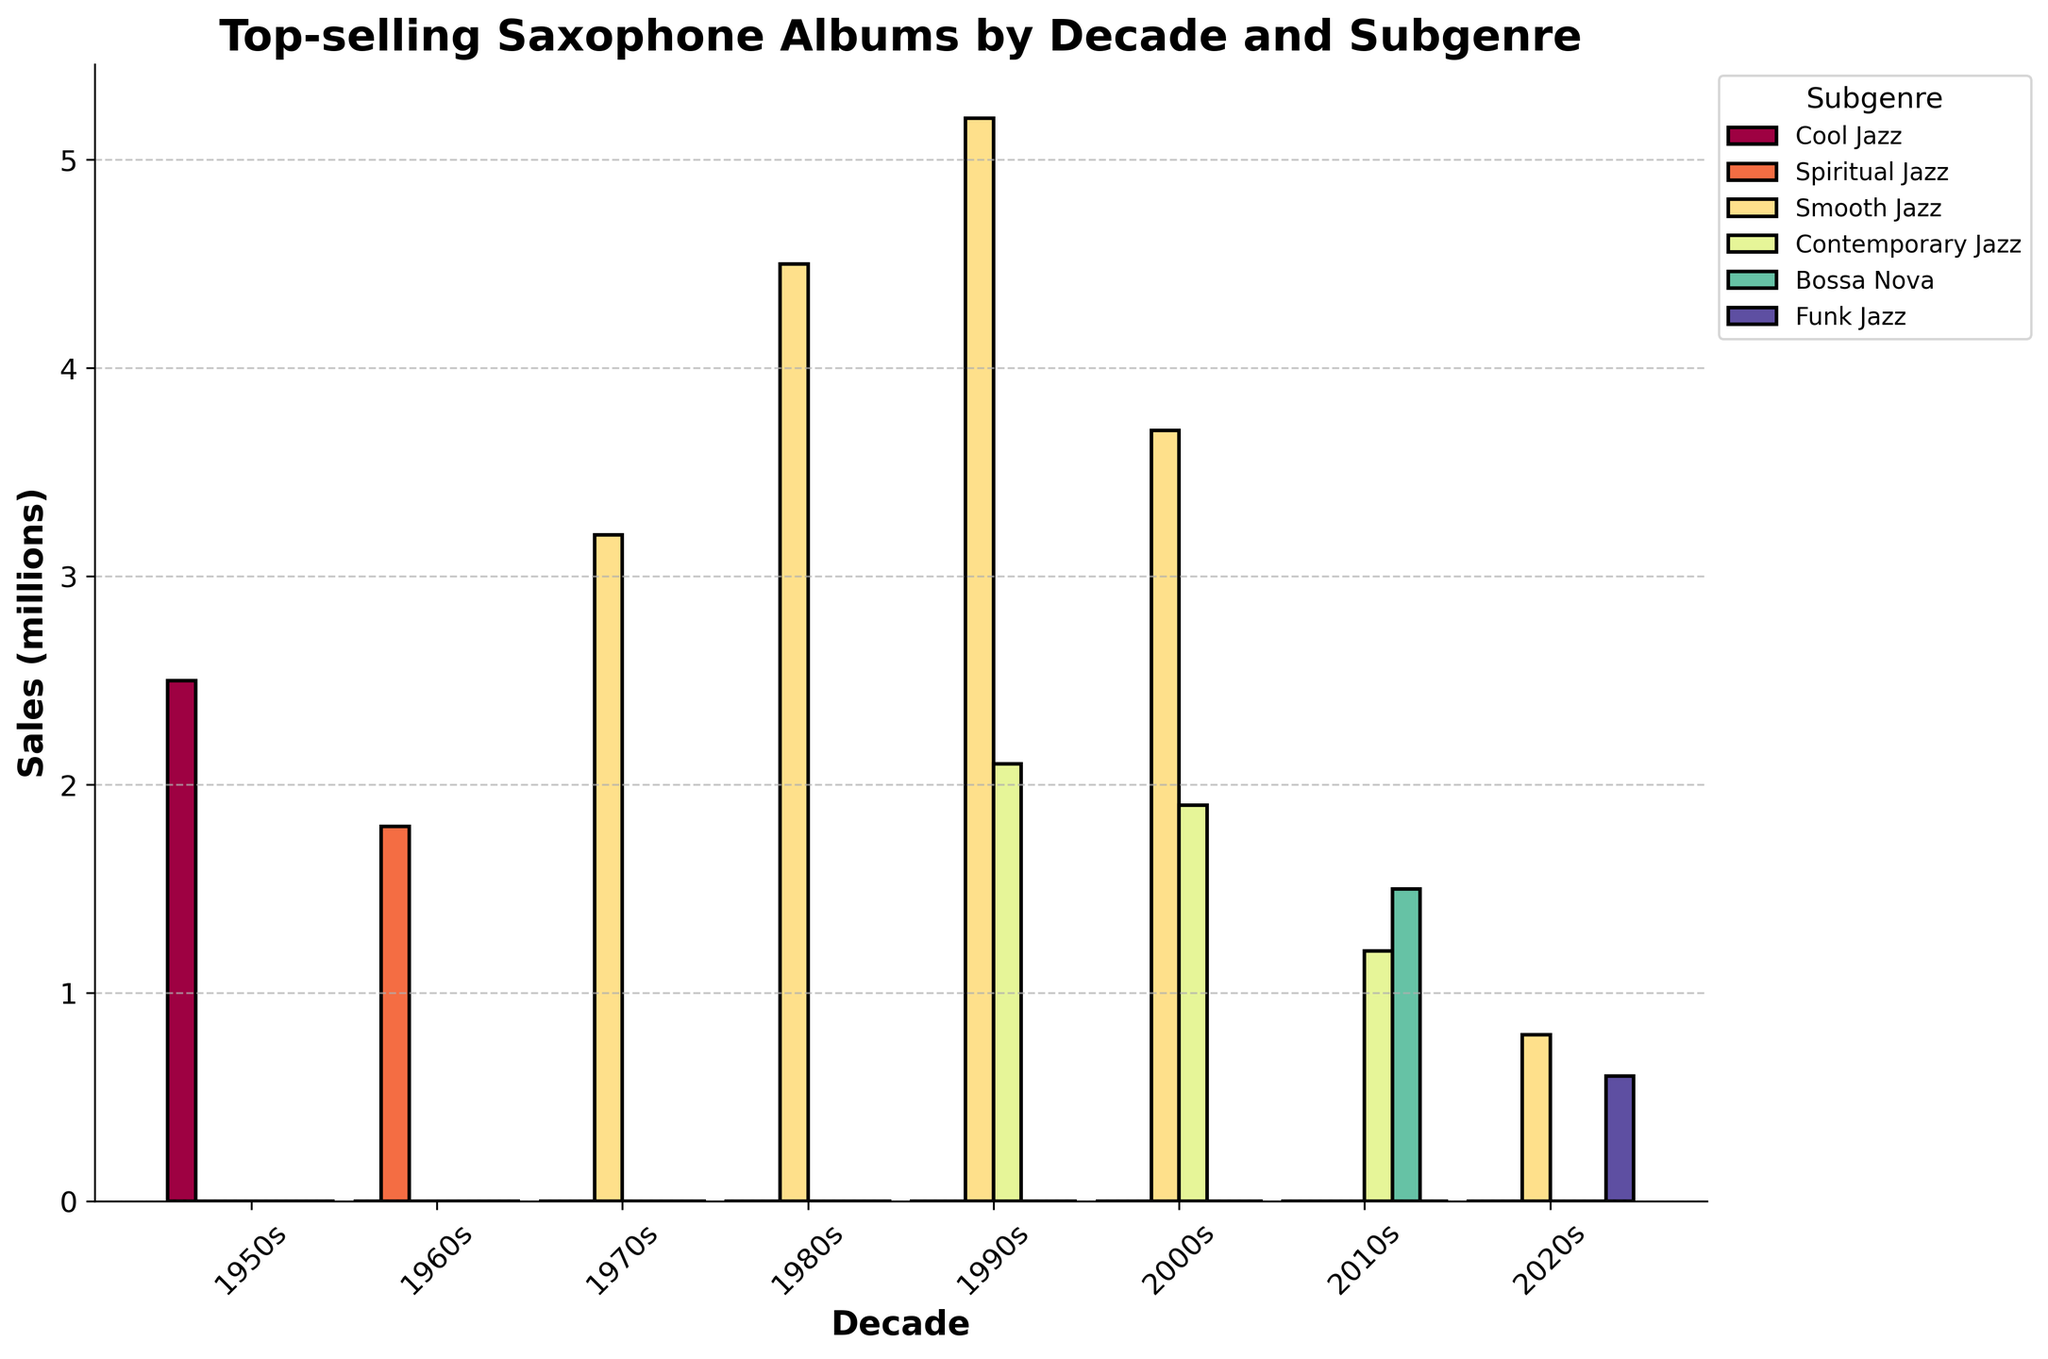What's the top-selling saxophone album of the 1980s? Look for the tallest bar in the decade labeled '1980s' and identify the corresponding album name in the subgenre with the highest sales.
Answer: Kenny G Which decade had the highest total sales for Smooth Jazz albums? Calculate the total sales for Smooth Jazz in each decade and compare them. The 1990s decade has the highest total with 5.2 + 2.1 = 7.3 million.
Answer: 1990s What is the combined sales total for Kenny G albums across all decades? Sum the sales of all Kenny G albums: 4.5 (1980s) + 5.2 (1990s) + 3.7 (2000s) + 1.5 (2010s) + 0.8 (2020s) = 15.7.
Answer: 15.7 million How does the total sales of Dave Koz's albums in the 1990s compare to the 2000s? Compare the sales values directly: 2.1 (1990s) - 1.9 (2000s) = 0.2. Dave Koz's albums in the 1990s had 0.2 million more sales than in the 2000s.
Answer: 0.2 million more What subgenre has the highest overall sales in the 2000s? Sum the sales of each subgenre in the 2000s and compare: Smooth Jazz (3.7) vs Contemporary Jazz (1.9). Smooth Jazz has higher sales.
Answer: Smooth Jazz Which decade showed the lowest sales for Cool Jazz? Since there is only one Cool Jazz album and it is in the 1950s, subsequent decades have zero sales. Therefore, any decade other than the 1950s has the lowest sales.
Answer: Any decade other than 1950s What is the difference in sales between the best-selling album of the 1970s and the best-selling album of the 2000s? Identify the best-selling albums for each decade: Breezin' (3.2 million) for the 1970s and At Last... The Duets Album (3.7 million) for the 2000s. The difference is 3.7 - 3.2 = 0.5 million.
Answer: 0.5 million How many total albums are represented in the chart for the 2020s? Count the number of unique albums for the 2020s: New Standards and A New Day. There are 2 albums.
Answer: 2 albums What is the average sales per album for the albums listed in the 2010s? Sum the sales of albums in the 2010s and divide by the number of albums: (1.5 + 1.2) / 2 = 1.35 million.
Answer: 1.35 million Which subgenre appears most frequently among the top-selling albums? Count the occurrences of each subgenre: Smooth Jazz (5), Contemporary Jazz (3), Cool Jazz (1), Spiritual Jazz (1), Bossa Nova (1), Funk Jazz (1). Smooth Jazz appears most frequently.
Answer: Smooth Jazz 